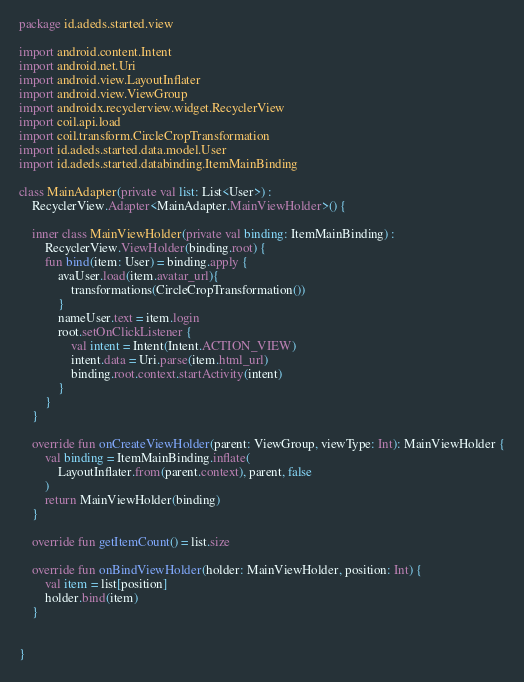<code> <loc_0><loc_0><loc_500><loc_500><_Kotlin_>package id.adeds.started.view

import android.content.Intent
import android.net.Uri
import android.view.LayoutInflater
import android.view.ViewGroup
import androidx.recyclerview.widget.RecyclerView
import coil.api.load
import coil.transform.CircleCropTransformation
import id.adeds.started.data.model.User
import id.adeds.started.databinding.ItemMainBinding

class MainAdapter(private val list: List<User>) :
    RecyclerView.Adapter<MainAdapter.MainViewHolder>() {

    inner class MainViewHolder(private val binding: ItemMainBinding) :
        RecyclerView.ViewHolder(binding.root) {
        fun bind(item: User) = binding.apply {
            avaUser.load(item.avatar_url){
                transformations(CircleCropTransformation())
            }
            nameUser.text = item.login
            root.setOnClickListener {
                val intent = Intent(Intent.ACTION_VIEW)
                intent.data = Uri.parse(item.html_url)
                binding.root.context.startActivity(intent)
            }
        }
    }

    override fun onCreateViewHolder(parent: ViewGroup, viewType: Int): MainViewHolder {
        val binding = ItemMainBinding.inflate(
            LayoutInflater.from(parent.context), parent, false
        )
        return MainViewHolder(binding)
    }

    override fun getItemCount() = list.size

    override fun onBindViewHolder(holder: MainViewHolder, position: Int) {
        val item = list[position]
        holder.bind(item)
    }


}</code> 